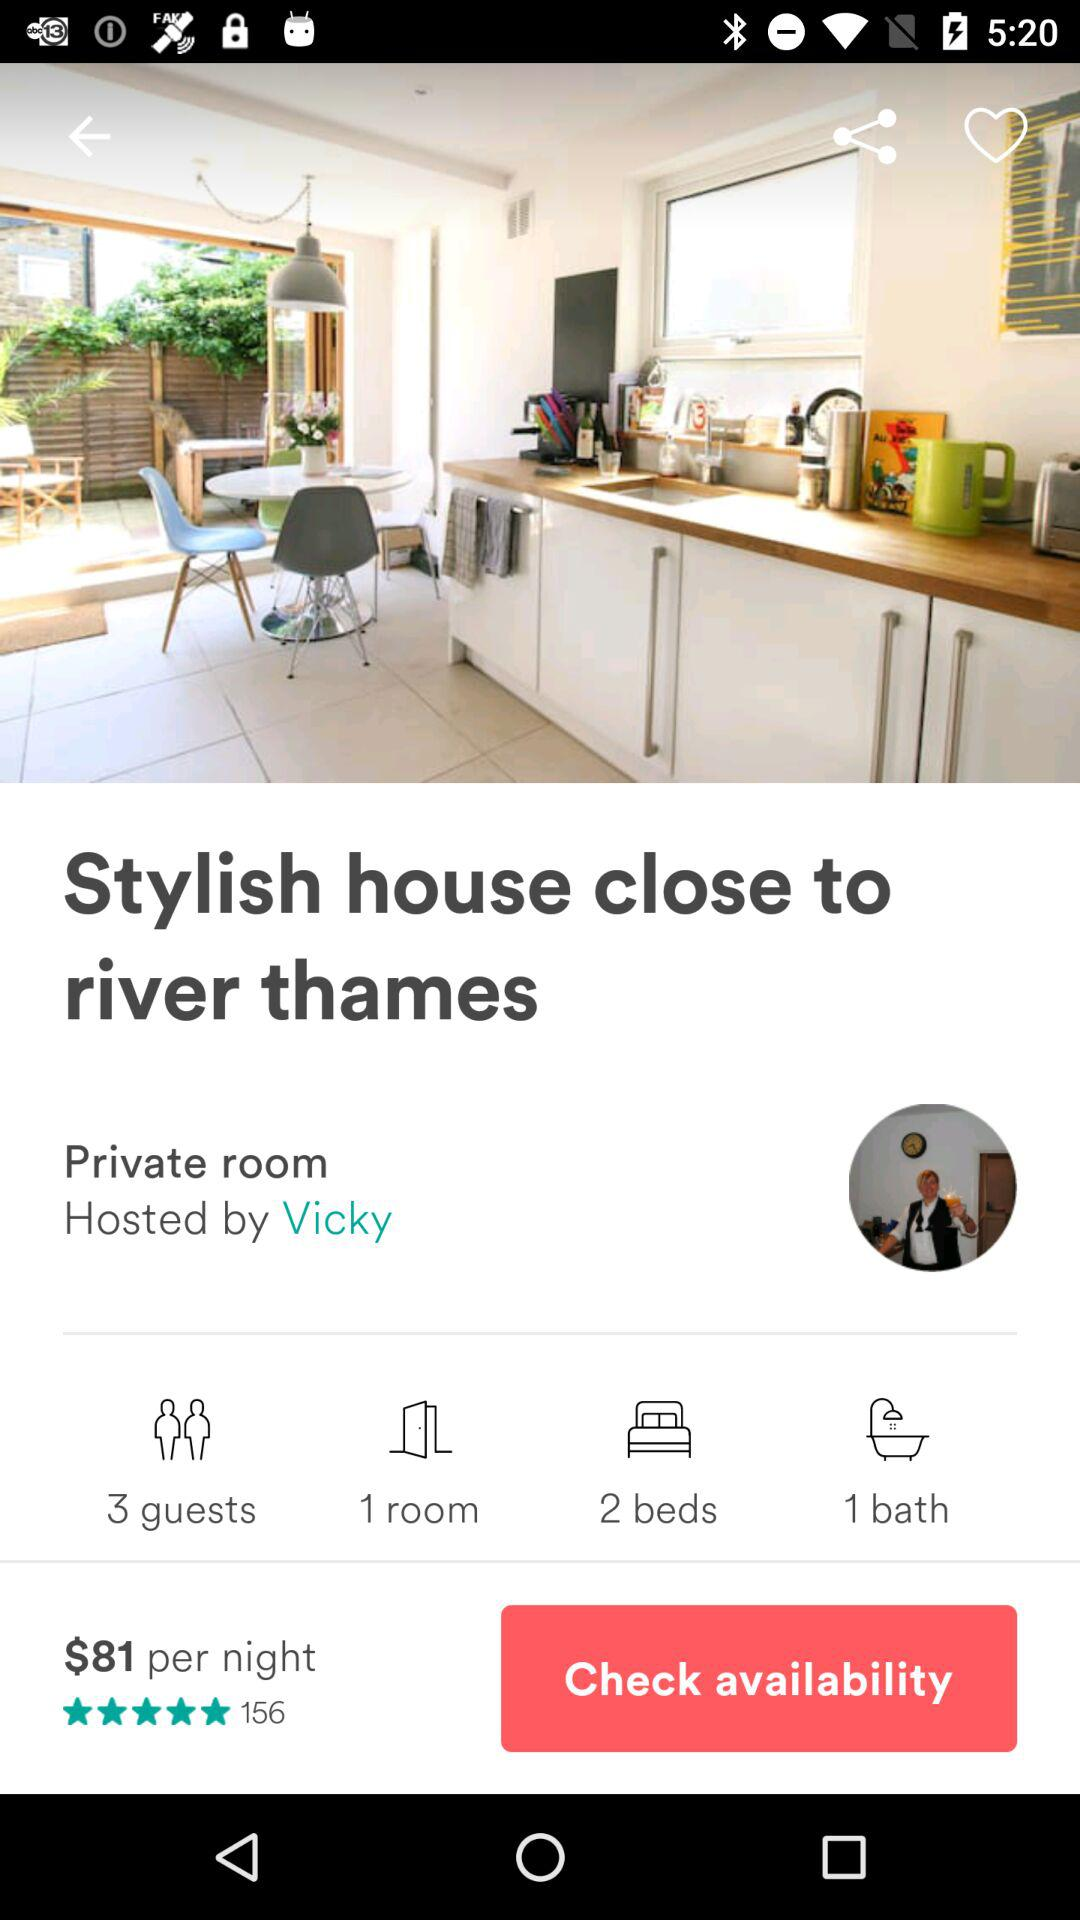How many people rated the hotel? The hotel is rated by 156 people. 